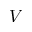Convert formula to latex. <formula><loc_0><loc_0><loc_500><loc_500>V</formula> 